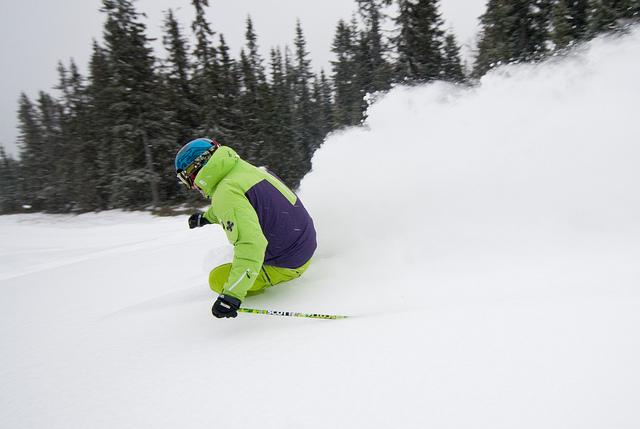Is there snow on the trees?
Be succinct. Yes. What is the white, powdery stuff flying in the air?
Give a very brief answer. Snow. What is covering the ground?
Concise answer only. Snow. What is in his hand?
Write a very short answer. Ski pole. 